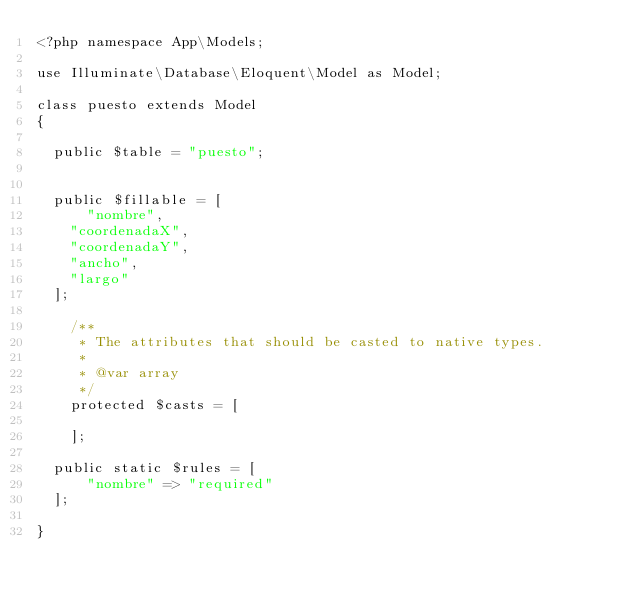Convert code to text. <code><loc_0><loc_0><loc_500><loc_500><_PHP_><?php namespace App\Models;

use Illuminate\Database\Eloquent\Model as Model;

class puesto extends Model
{
    
	public $table = "puesto";
    

	public $fillable = [
	    "nombre",
		"coordenadaX",
		"coordenadaY",
		"ancho",
		"largo"
	];

    /**
     * The attributes that should be casted to native types.
     *
     * @var array
     */
    protected $casts = [
        
    ];

	public static $rules = [
	    "nombre" => "required"
	];

}
</code> 